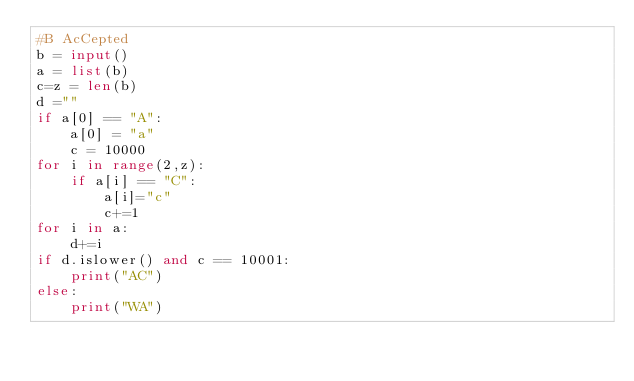Convert code to text. <code><loc_0><loc_0><loc_500><loc_500><_Python_>#B AcCepted
b = input()
a = list(b)
c=z = len(b)
d =""
if a[0] == "A":
    a[0] = "a"
    c = 10000
for i in range(2,z):
    if a[i] == "C":
        a[i]="c"
        c+=1
for i in a:
    d+=i
if d.islower() and c == 10001:
    print("AC")
else:
    print("WA")
    
    </code> 